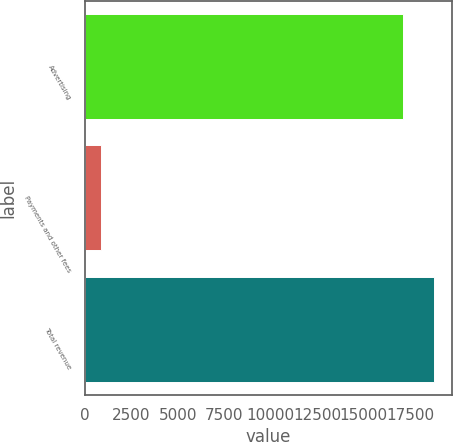Convert chart to OTSL. <chart><loc_0><loc_0><loc_500><loc_500><bar_chart><fcel>Advertising<fcel>Payments and other fees<fcel>Total revenue<nl><fcel>17079<fcel>849<fcel>18786.9<nl></chart> 